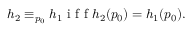Convert formula to latex. <formula><loc_0><loc_0><loc_500><loc_500>\begin{array} { r } { h _ { 2 } \equiv _ { p _ { 0 } } h _ { 1 } i f f h _ { 2 } ( p _ { 0 } ) = h _ { 1 } ( p _ { 0 } ) . } \end{array}</formula> 